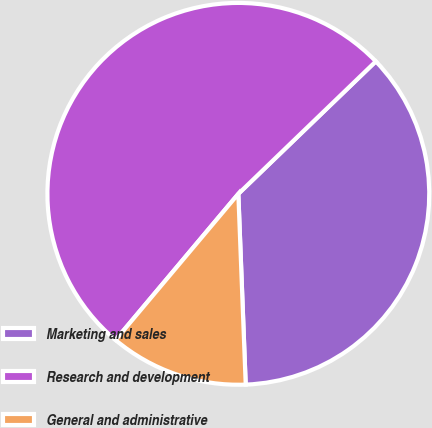<chart> <loc_0><loc_0><loc_500><loc_500><pie_chart><fcel>Marketing and sales<fcel>Research and development<fcel>General and administrative<nl><fcel>36.59%<fcel>51.67%<fcel>11.74%<nl></chart> 